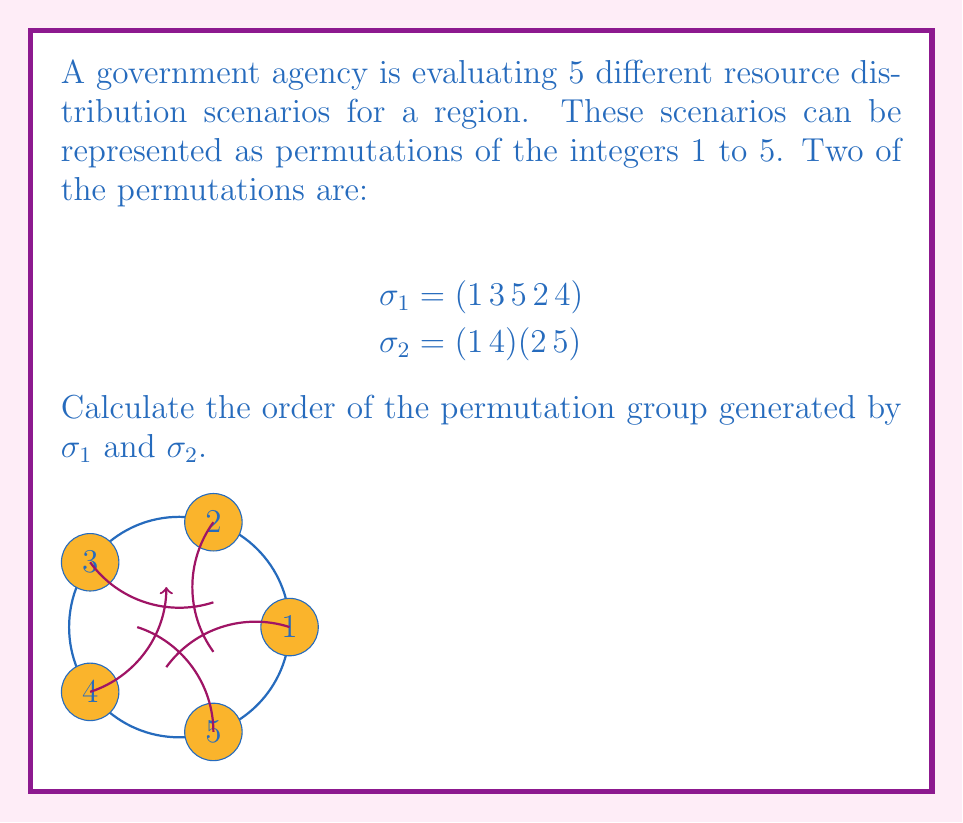Can you answer this question? To find the order of the permutation group, we need to follow these steps:

1) First, let's determine the order of each permutation:
   
   $\sigma_1 = (1 \, 3 \, 5 \, 2 \, 4)$ is a 5-cycle, so its order is 5.
   $\sigma_2 = (1 \, 4)(2 \, 5)$ is a product of two disjoint 2-cycles, so its order is lcm(2,2) = 2.

2) Now, we need to find the order of the group generated by these permutations. Let's call this group G.

3) We can see that $\sigma_1^5 = e$ and $\sigma_2^2 = e$, where e is the identity permutation.

4) The key observation is that $\sigma_2 \sigma_1 \sigma_2^{-1} = \sigma_1^2$. This is because:
   
   $\sigma_2 \sigma_1 \sigma_2^{-1} = (1 \, 4)(2 \, 5)(1 \, 3 \, 5 \, 2 \, 4)(1 \, 4)(2 \, 5) = (1 \, 5 \, 4 \, 2 \, 3) = \sigma_1^2$

5) This relation shows that G is isomorphic to the Frobenius group of order 20, which is a semidirect product of a cyclic group of order 5 and a cyclic group of order 4.

6) Therefore, the order of G is 20.

We can verify this by listing all elements:
$e, \sigma_1, \sigma_1^2, \sigma_1^3, \sigma_1^4, \sigma_2, \sigma_2\sigma_1, \sigma_2\sigma_1^2, \sigma_2\sigma_1^3, \sigma_2\sigma_1^4, \sigma_1\sigma_2, \sigma_1^2\sigma_2, \sigma_1^3\sigma_2, \sigma_1^4\sigma_2, \sigma_1\sigma_2\sigma_1, \sigma_1^2\sigma_2\sigma_1, \sigma_1^3\sigma_2\sigma_1, \sigma_1^4\sigma_2\sigma_1, \sigma_2\sigma_1\sigma_2, \sigma_1\sigma_2\sigma_1\sigma_2$
Answer: 20 